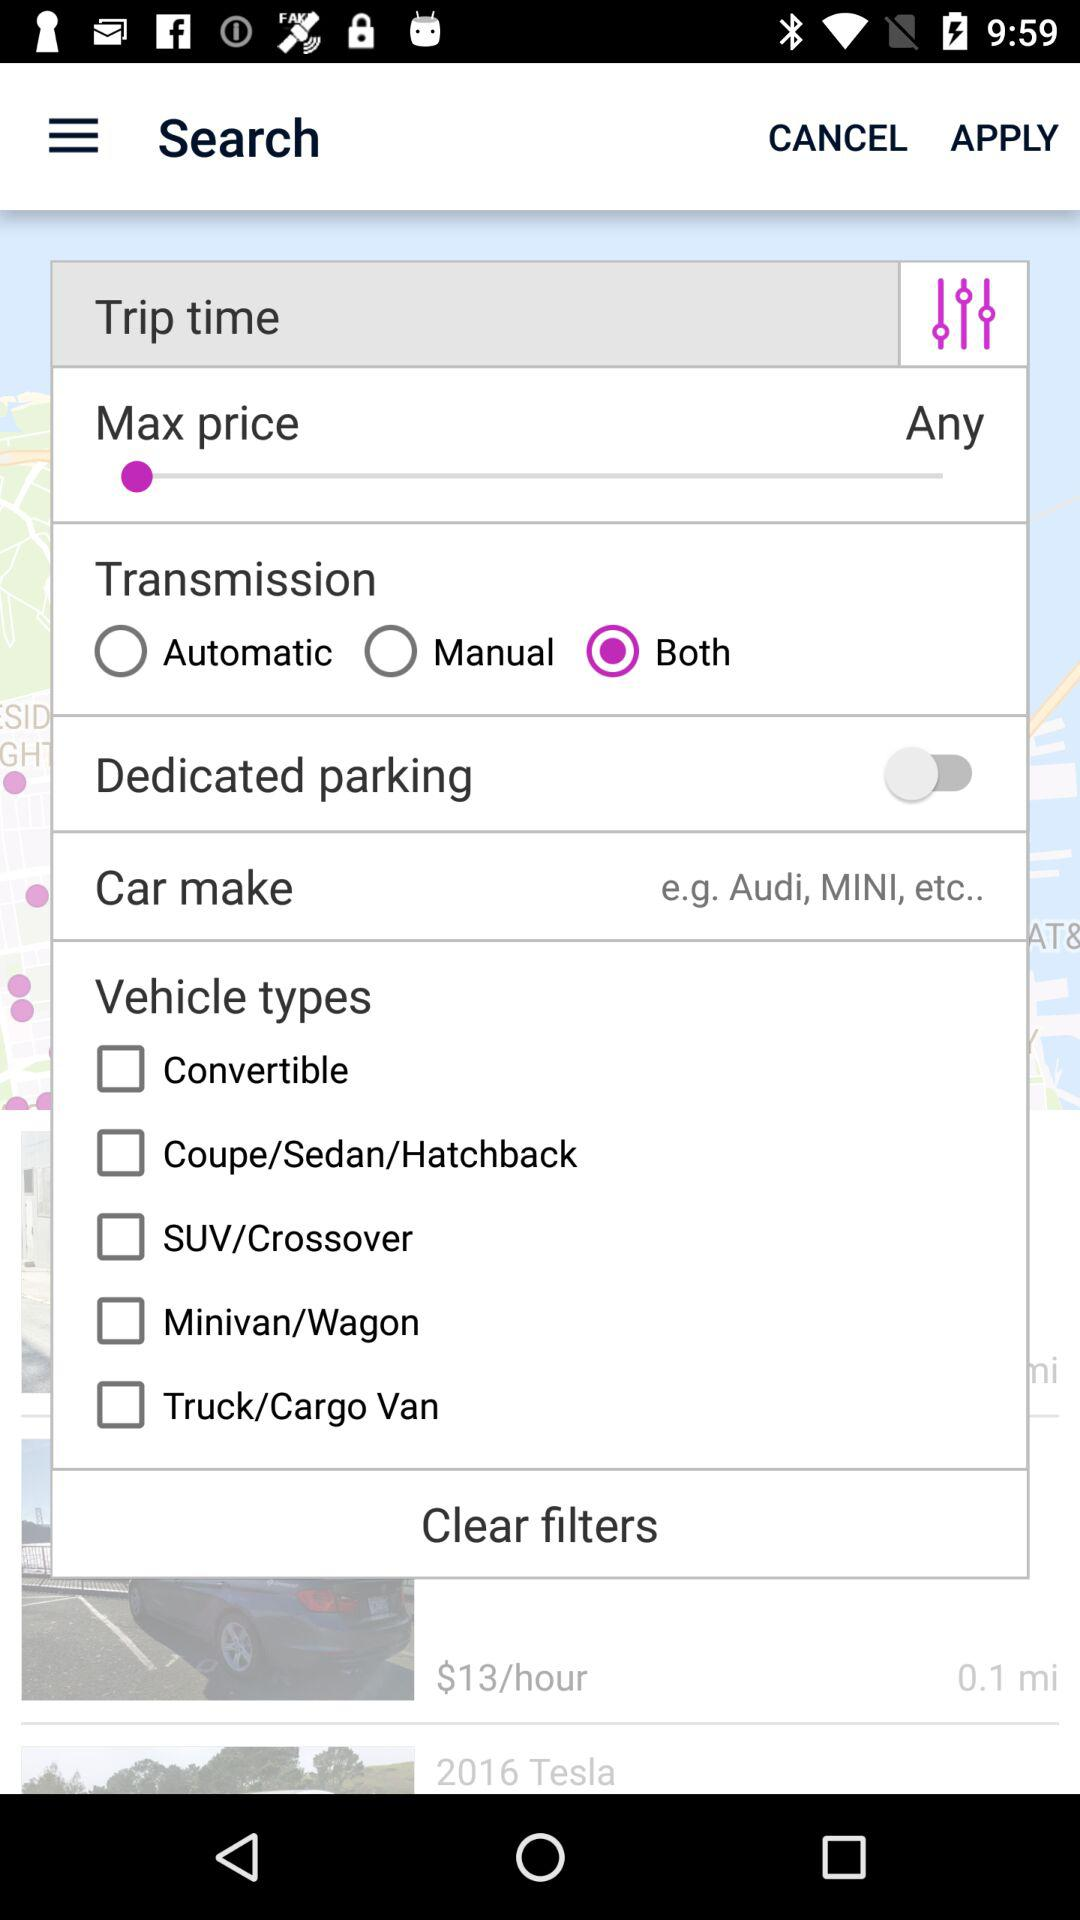What is the selected option for transmission? The selected option is "Both". 